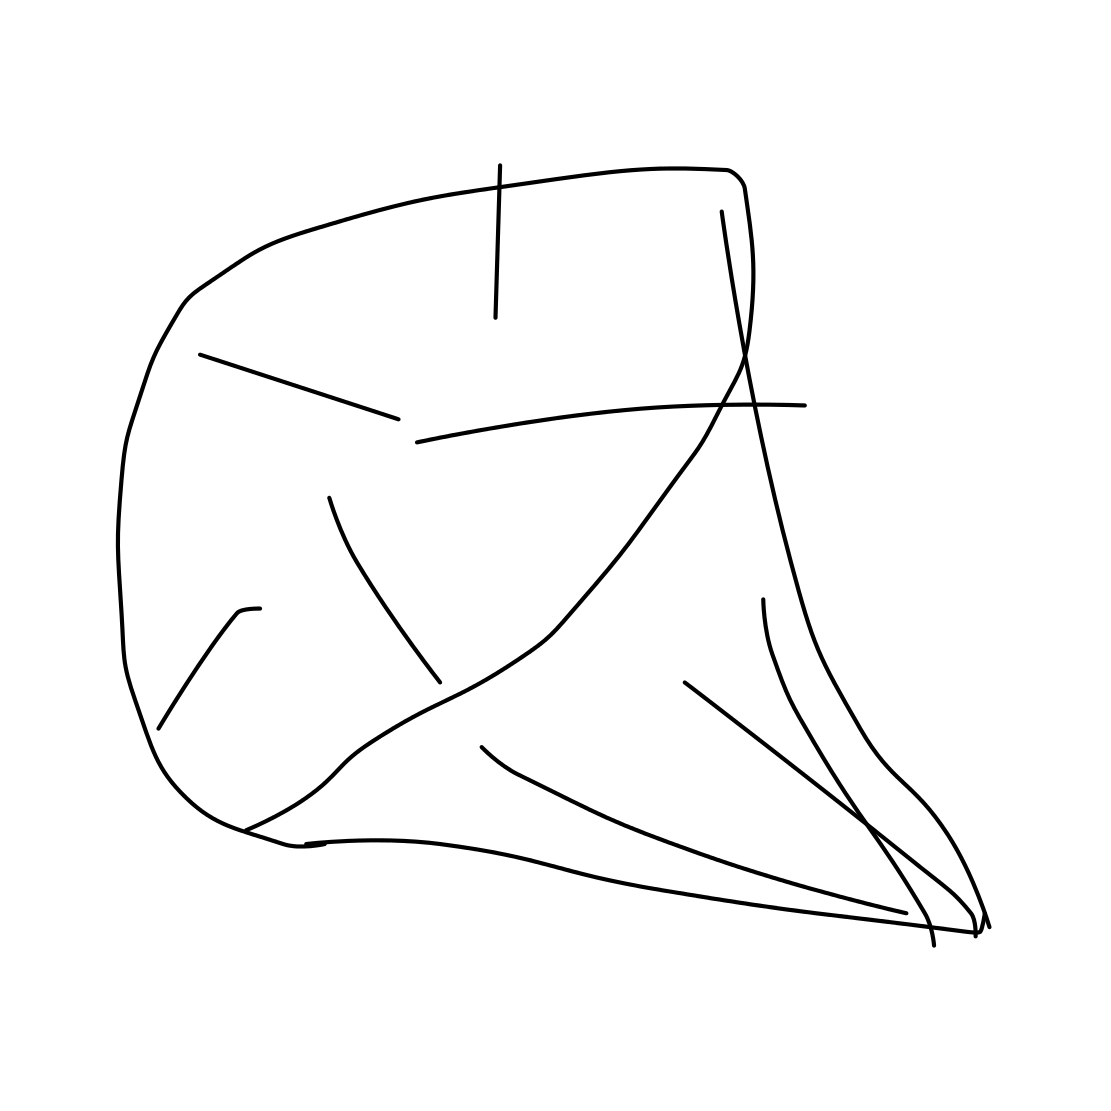How could an artist use this kind of image in their work? An artist might use such an abstract form to evoke emotions or provoke thought. It might be incorporated into a larger piece as a focal point or used as a motif to convey a theme, such as the complexity of nature or human emotion. 